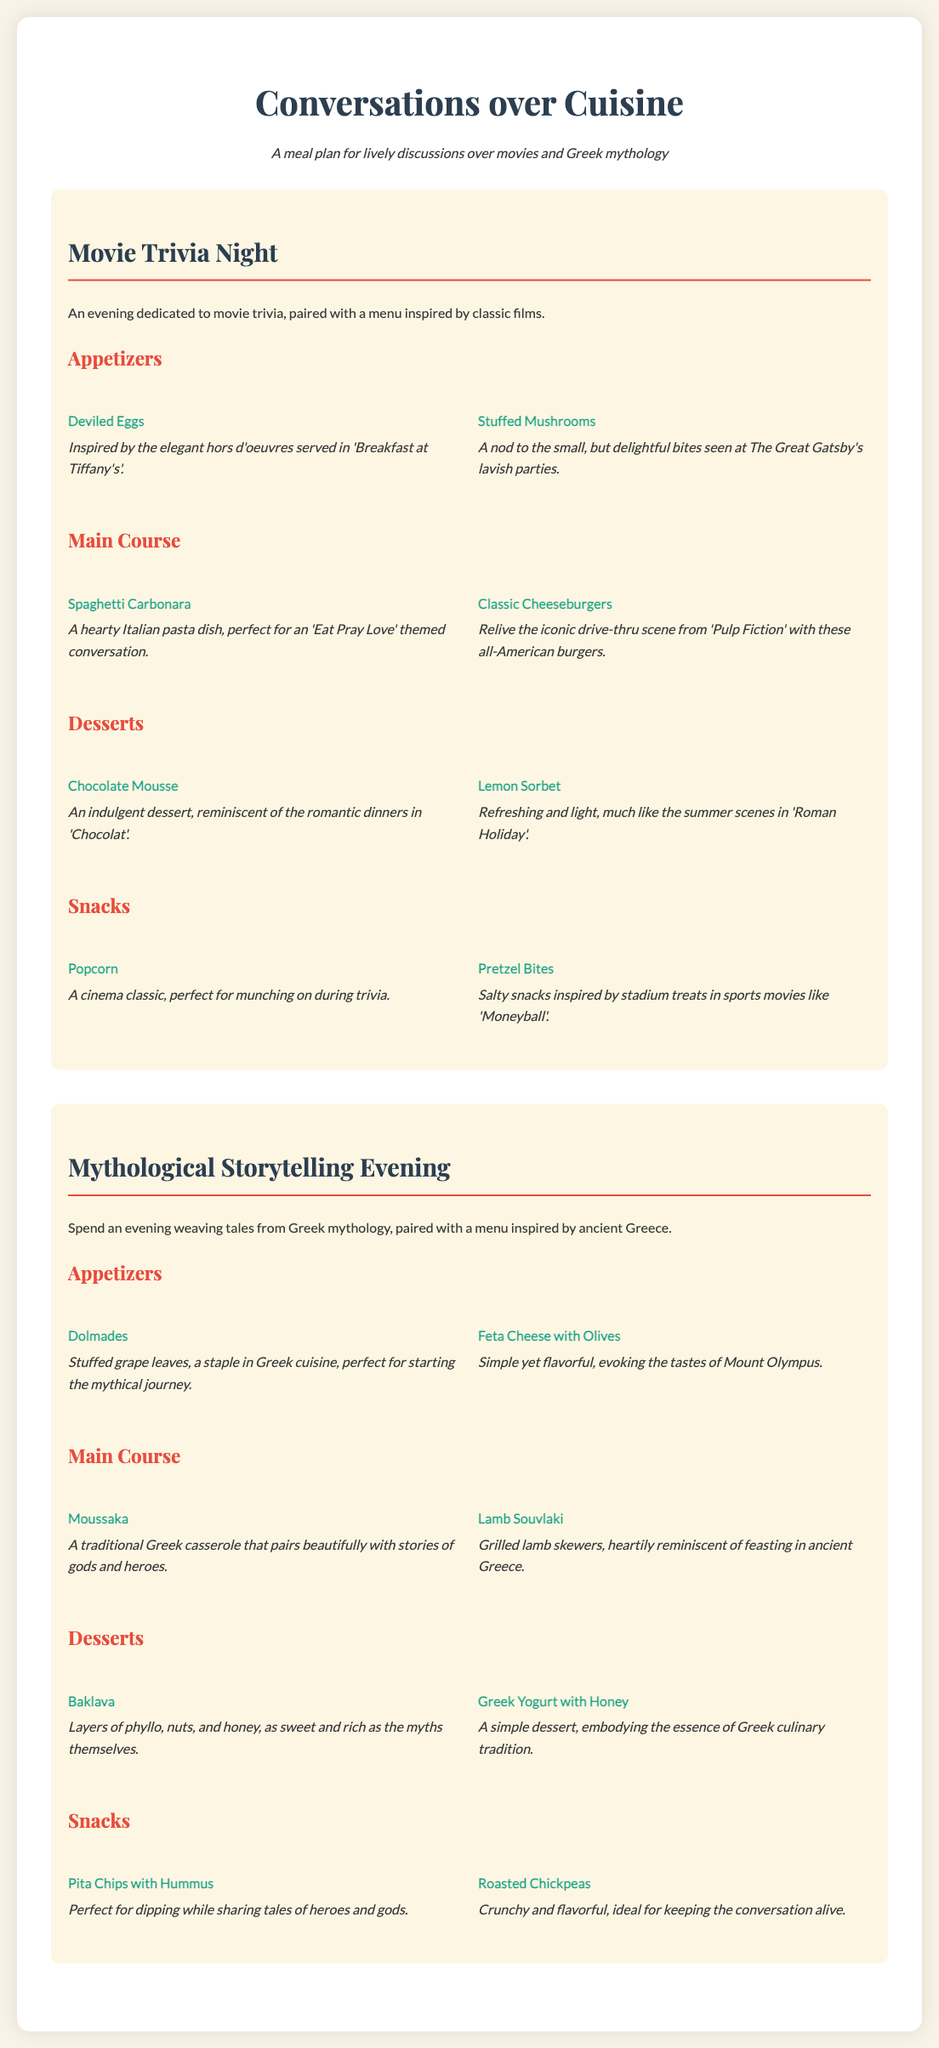What are the appetizers for Movie Trivia Night? The appetizers listed in the Movie Trivia Night section are Deviled Eggs and Stuffed Mushrooms.
Answer: Deviled Eggs, Stuffed Mushrooms What main course dish is inspired by 'Eat Pray Love'? The main course dish that is perfect for an 'Eat Pray Love' themed conversation is Spaghetti Carbonara.
Answer: Spaghetti Carbonara How many desserts are listed for Mythological Storytelling Evening? The desserts listed in the Mythological Storytelling Evening section are Baklava and Greek Yogurt with Honey, making a total of two desserts.
Answer: 2 Which snack is a cinema classic? The snack that is described as a cinema classic and perfect for munching on during trivia is Popcorn.
Answer: Popcorn What type of cheese is paired with olives in the Mythological Storytelling Evening menu? The type of cheese that is served with olives is Feta Cheese.
Answer: Feta Cheese What is a key feature of the document? The document is a meal plan created for fostering lively discussions through themed dining experiences.
Answer: Meal plan for lively discussions 